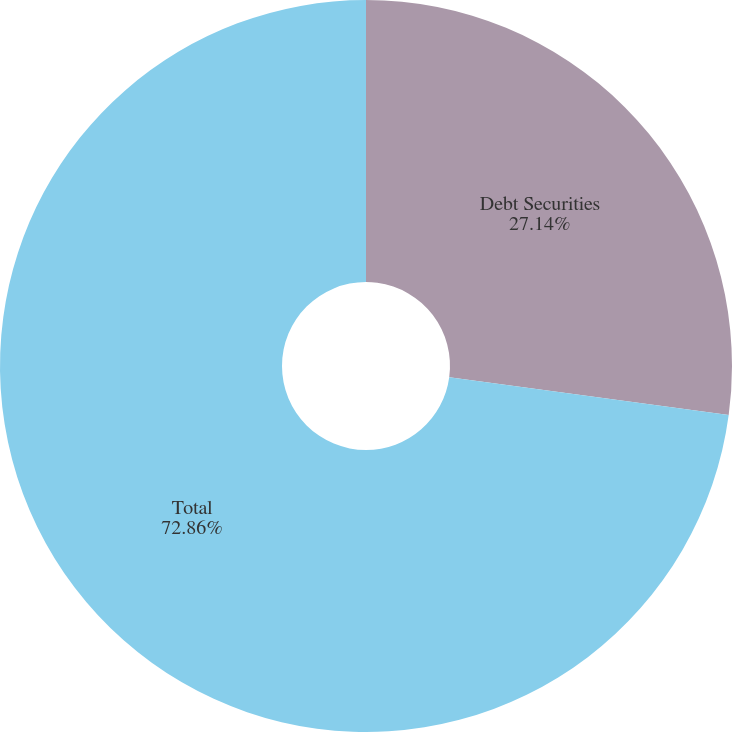Convert chart to OTSL. <chart><loc_0><loc_0><loc_500><loc_500><pie_chart><fcel>Debt Securities<fcel>Total<nl><fcel>27.14%<fcel>72.86%<nl></chart> 